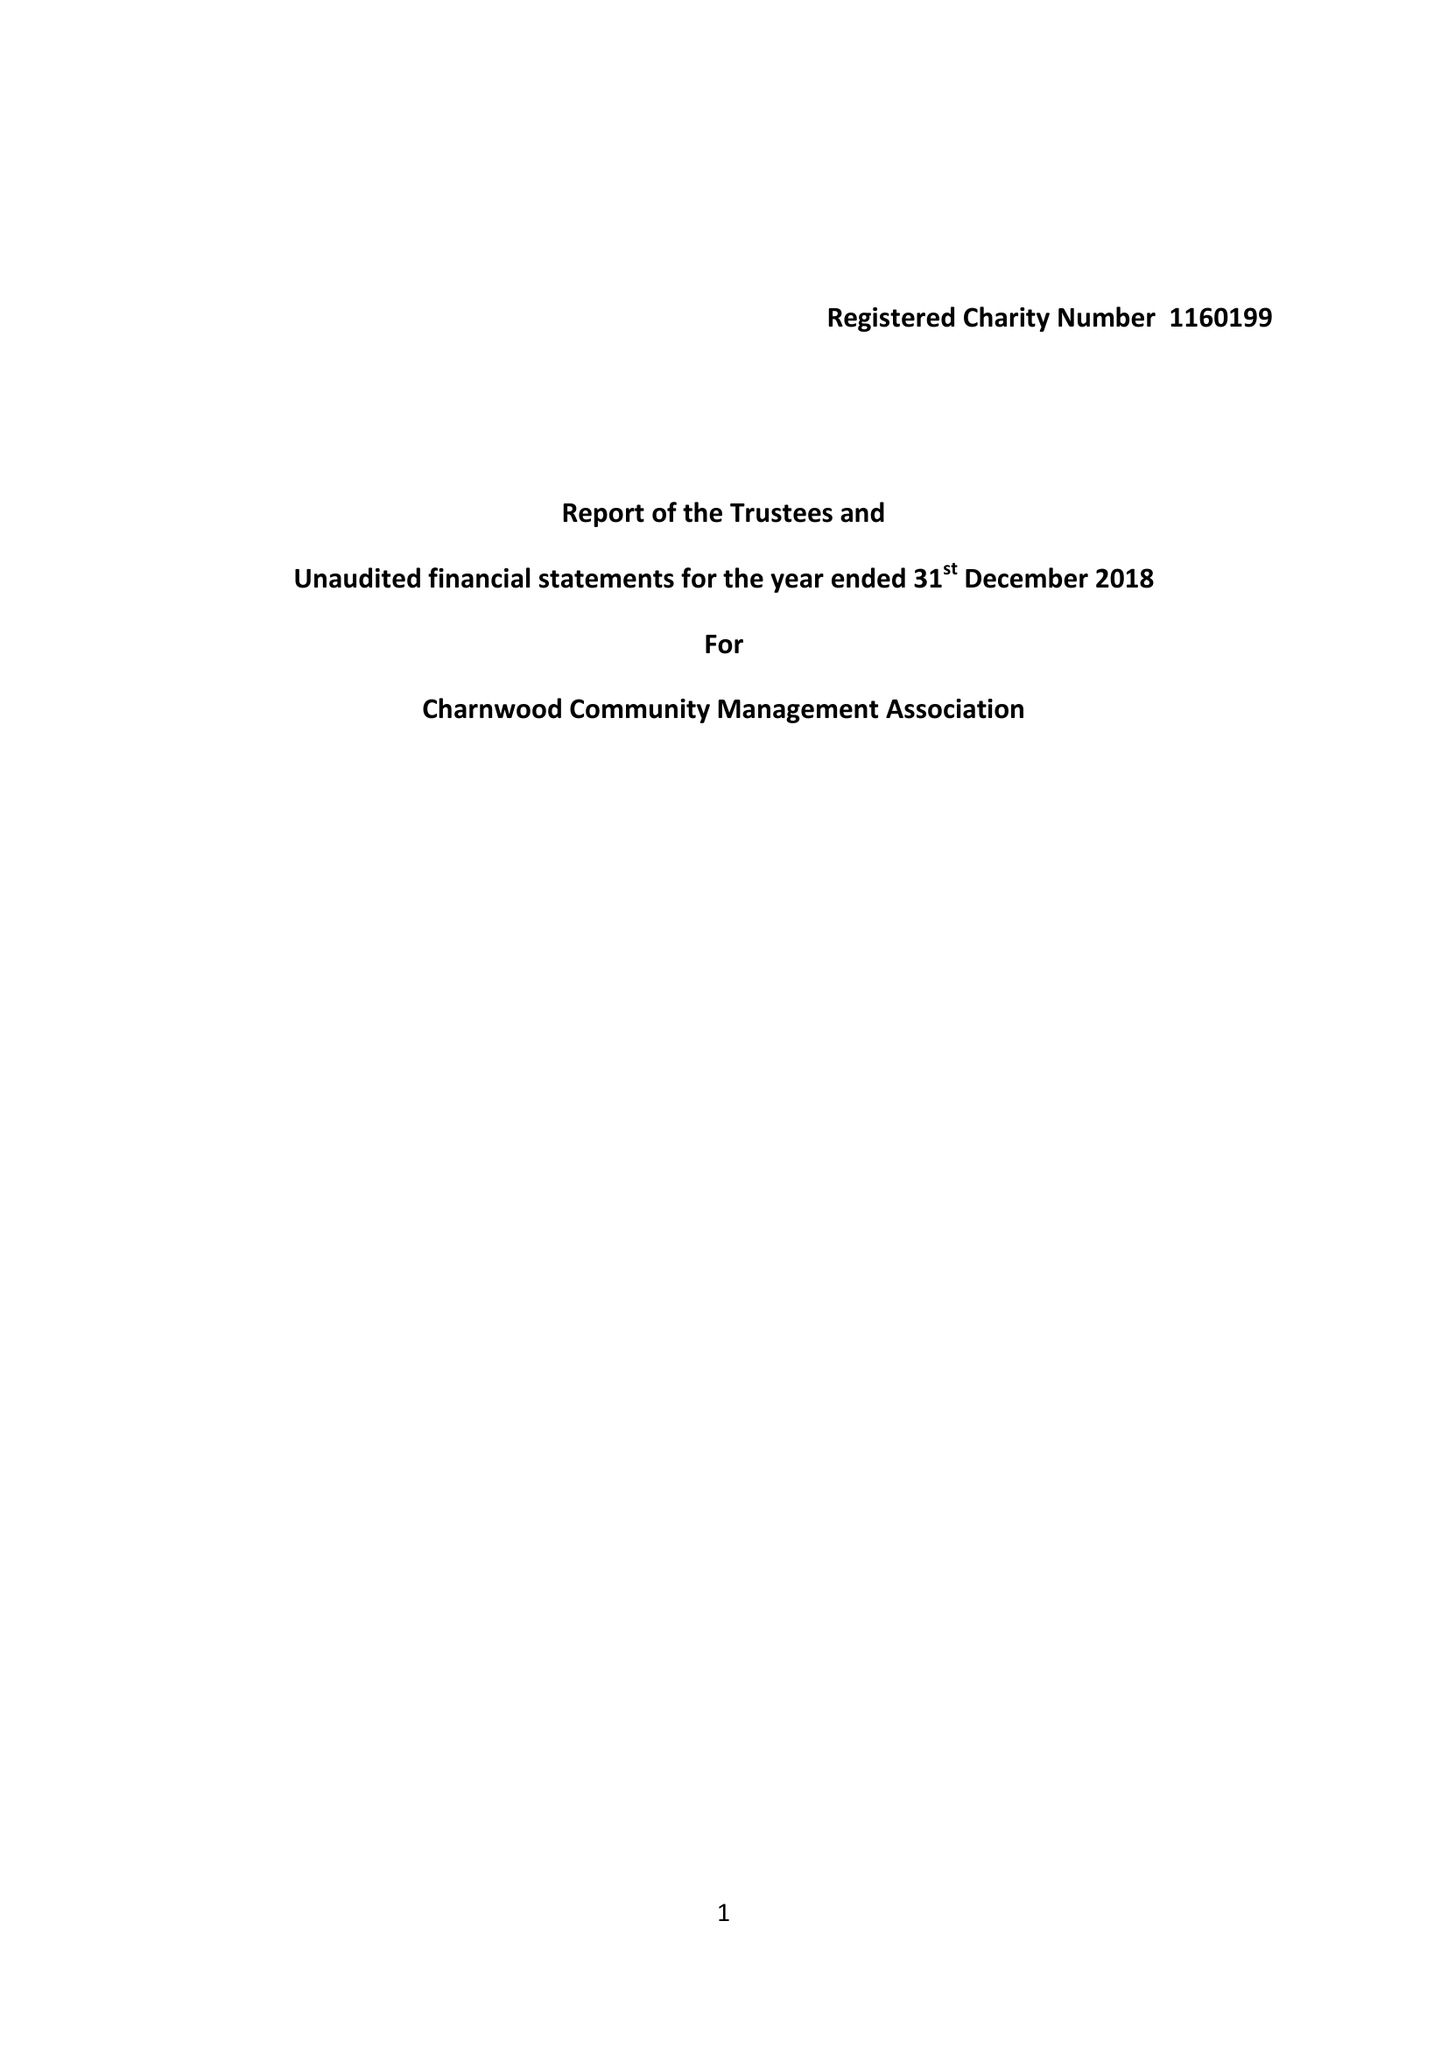What is the value for the address__post_town?
Answer the question using a single word or phrase. HITCHIN 